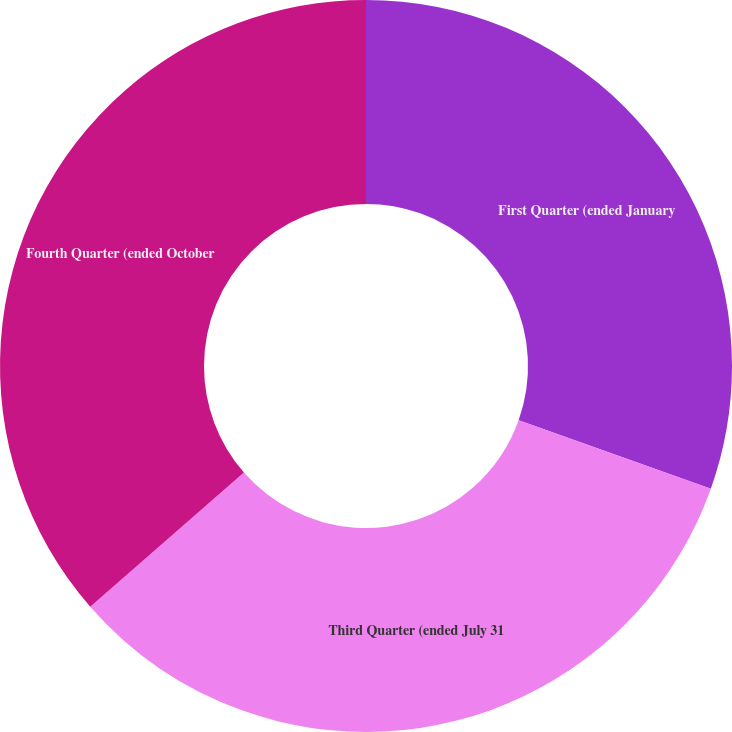<chart> <loc_0><loc_0><loc_500><loc_500><pie_chart><fcel>First Quarter (ended January<fcel>Third Quarter (ended July 31<fcel>Fourth Quarter (ended October<nl><fcel>30.44%<fcel>33.14%<fcel>36.42%<nl></chart> 